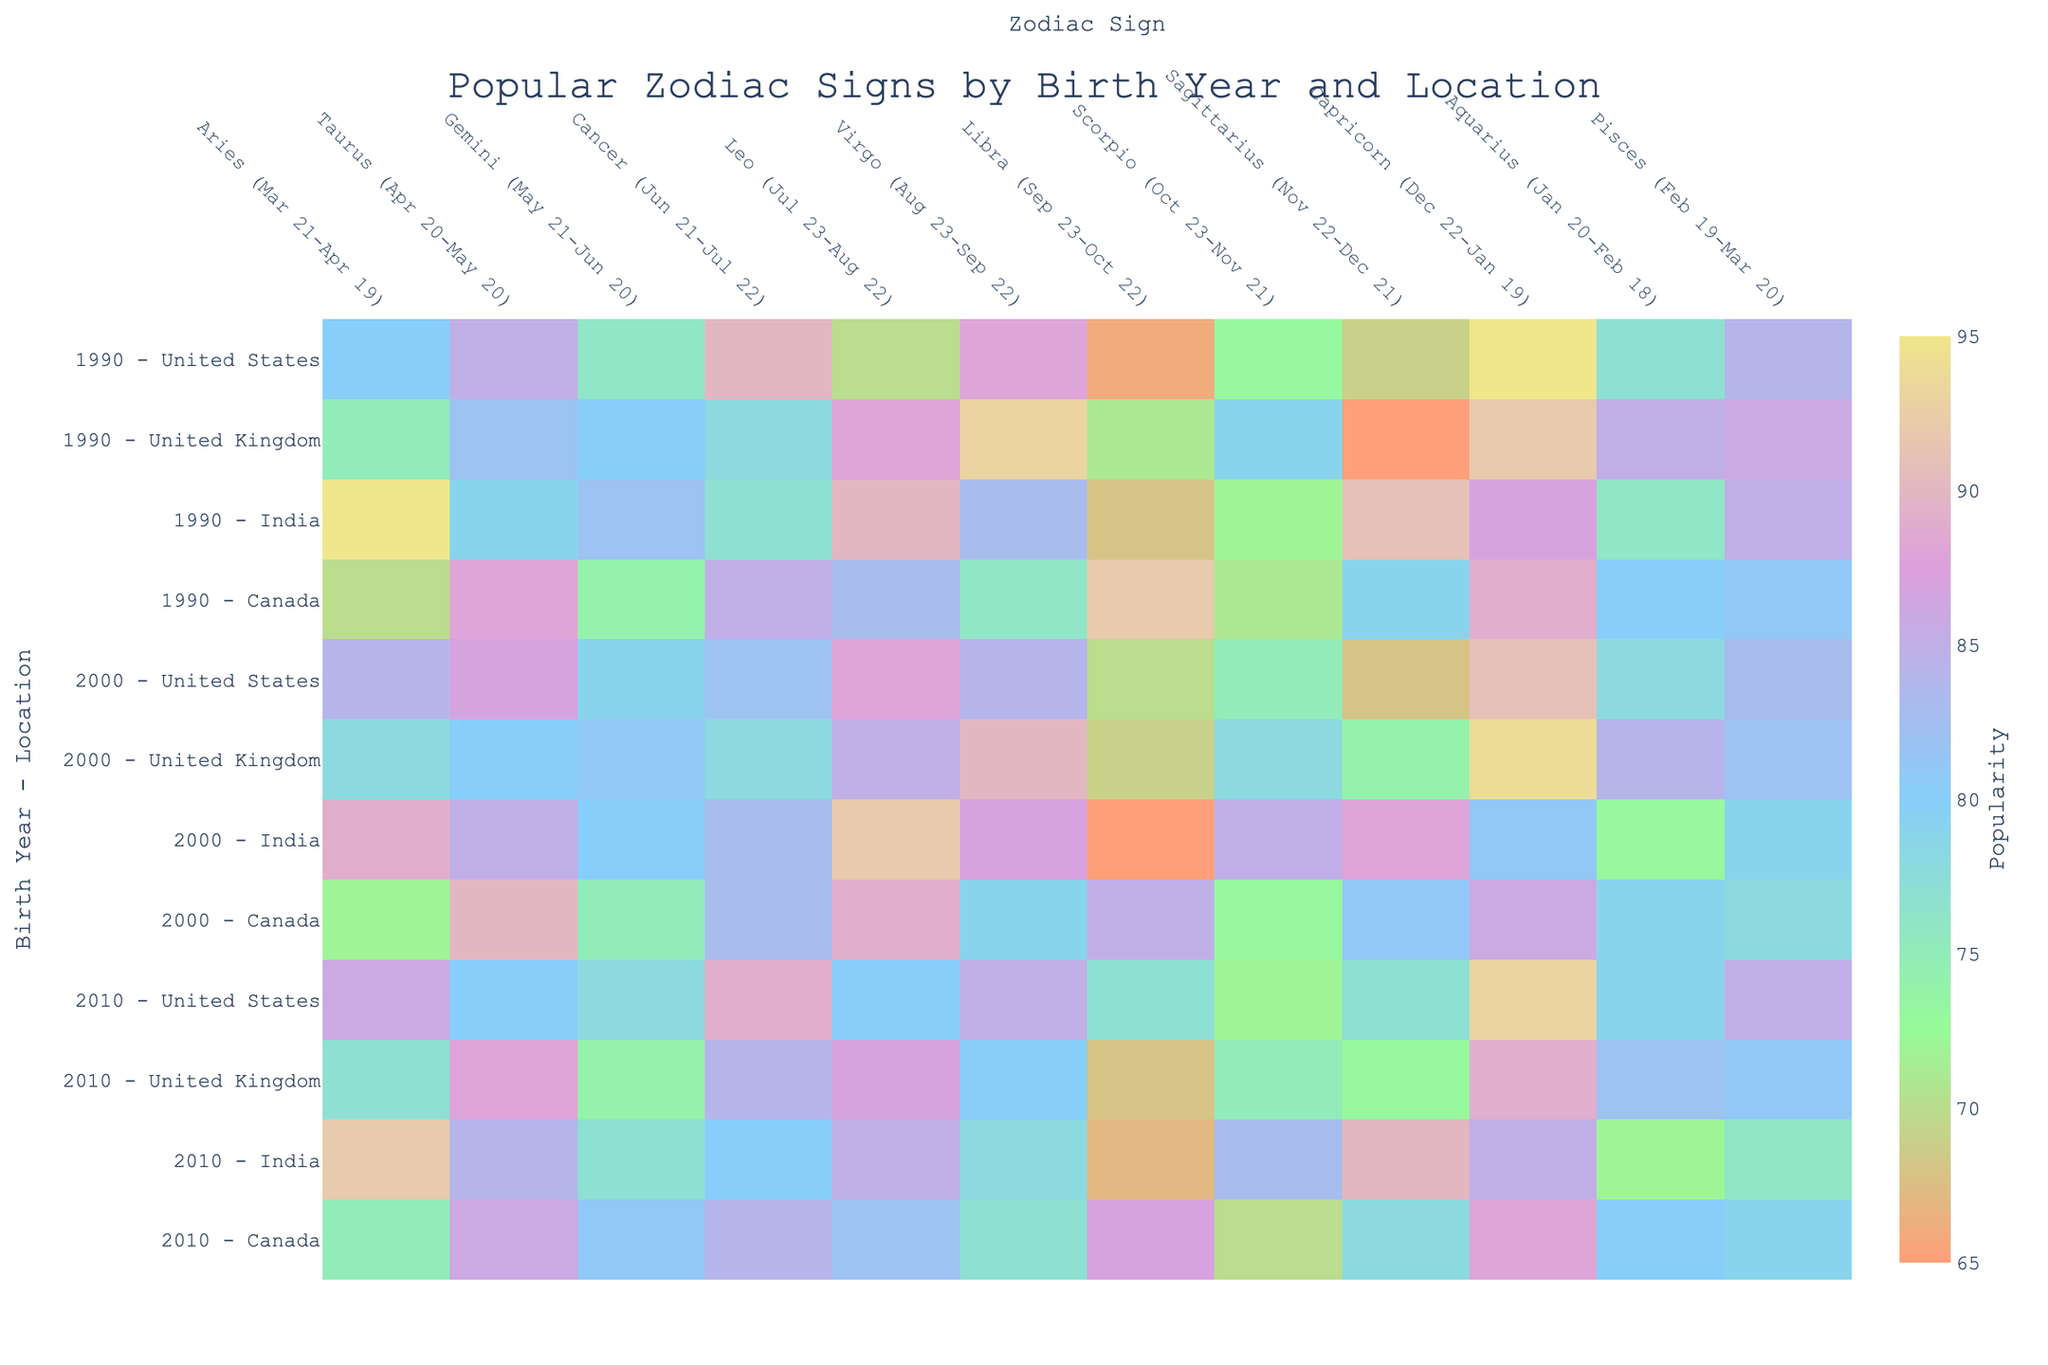What is the title of the figure? The title of the figure is located at the top center of the plot.
Answer: Popular Zodiac Signs by Birth Year and Location What is the maximum popularity value displayed for any zodiac sign? Look for the highest number in the heatmap's colorbar, which displays the numerical range of the popularity values.
Answer: 95 Which birth year and geographical location combination has the highest popularity for the Capricorn sign? Locate the Capricorn column and look for the highest value in that column, then trace it to the corresponding birth year and location.
Answer: 1990 - United States How does the popularity of the Leo sign in Canada compare between the years 1990 and 2010? Find the popularity values for Leo in the columns corresponding to Canada for the years 1990 and 2010, then compare them.
Answer: 83 (1990) vs. 82 (2010); almost the same What is the average popularity of Aries across all locations for the year 2000? Add the popularity values for Aries in the year 2000 across all locations and divide by the number of locations (4 in this case). (84 + 78 + 89 + 72) = 323 / 4 = 80.75
Answer: 80.75 Which zodiac sign has the highest popularity in the United Kingdom in the year 2010? Locate the data for the United Kingdom in 2010, then find the zodiac sign with the highest popularity value in that row.
Answer: Taurus (88) Does the popularity of the Virgo sign increase or decrease from 1990 to 2000 in the United States? Find the popularity values for Virgo in the United States for 1990 and 2000, then determine if there is an increase or decrease.
Answer: Decrease (from 88 to 84) Which geographical location has the most consistent popularity values across all zodiac signs for the birth year 1990? Examine the variability of the popularity values across all zodiac signs for each location in 1990 to identify the one with the least fluctuation.
Answer: Canada What is the range of popularity values for the zodiac sign Pisces in India across all birth years? Locate the popularity values for Pisces in India for the years 1990, 2000, and 2010, then calculate the range (difference between the highest and lowest values). (85 - 76)
Answer: 9 What trend do you see in the popularity of the Sagittarius sign across the years in the United States? Observe the values corresponding to Sagittarius in the United States over the three years (1990, 2000, 2010) to identify any increasing, decreasing, or constant trends.
Answer: Decreasing (69, 68, 77) 